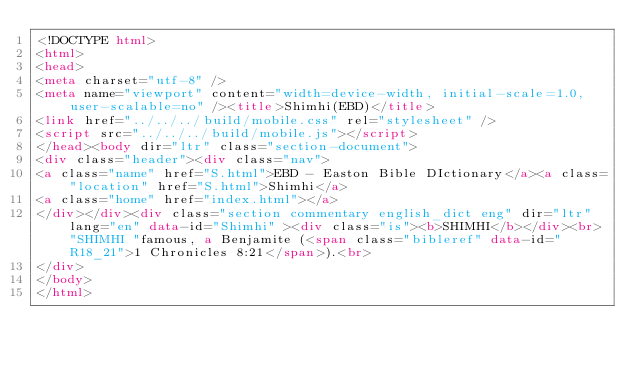<code> <loc_0><loc_0><loc_500><loc_500><_HTML_><!DOCTYPE html>
<html>
<head>
<meta charset="utf-8" />
<meta name="viewport" content="width=device-width, initial-scale=1.0, user-scalable=no" /><title>Shimhi(EBD)</title>
<link href="../../../build/mobile.css" rel="stylesheet" />
<script src="../../../build/mobile.js"></script>
</head><body dir="ltr" class="section-document">
<div class="header"><div class="nav">
<a class="name" href="S.html">EBD - Easton Bible DIctionary</a><a class="location" href="S.html">Shimhi</a>
<a class="home" href="index.html"></a>
</div></div><div class="section commentary english_dict eng" dir="ltr" lang="en" data-id="Shimhi" ><div class="is"><b>SHIMHI</b></div><br>"SHIMHI "famous, a Benjamite (<span class="bibleref" data-id="R18_21">1 Chronicles 8:21</span>).<br>
</div>
</body>
</html>
</code> 